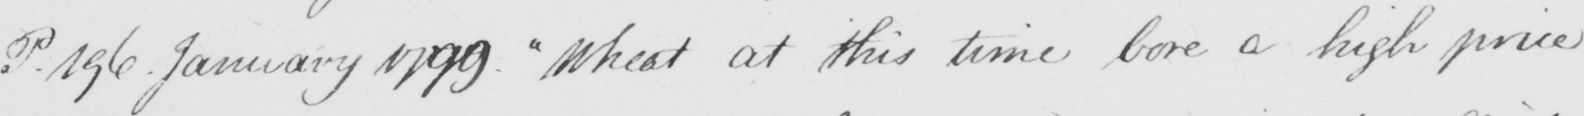Please provide the text content of this handwritten line. P. 196. January 1799. "Wheat at this time bore a high price 